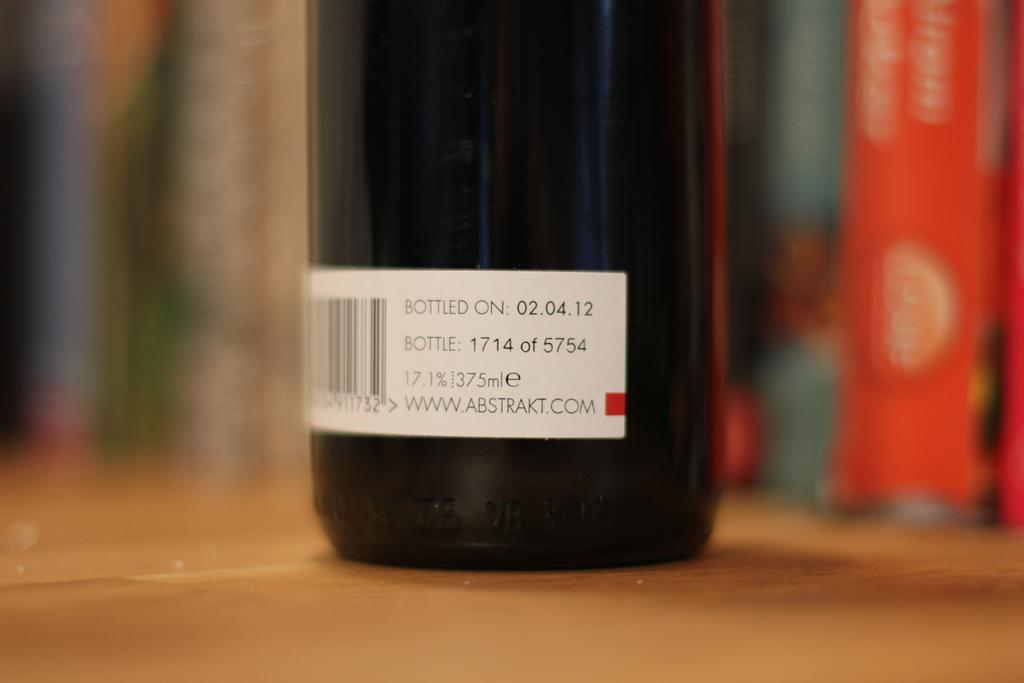<image>
Relay a brief, clear account of the picture shown. The bottled on date is 02/04/12 and it is 1714 of 5754 bottles. 